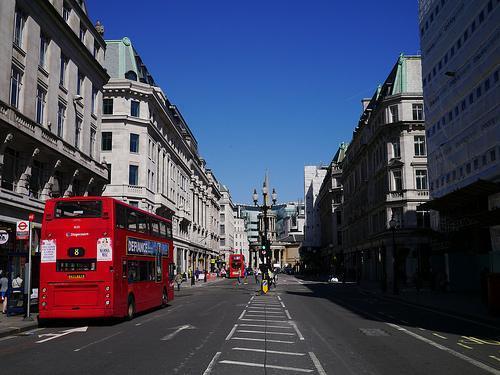How many buses are there?
Give a very brief answer. 2. 